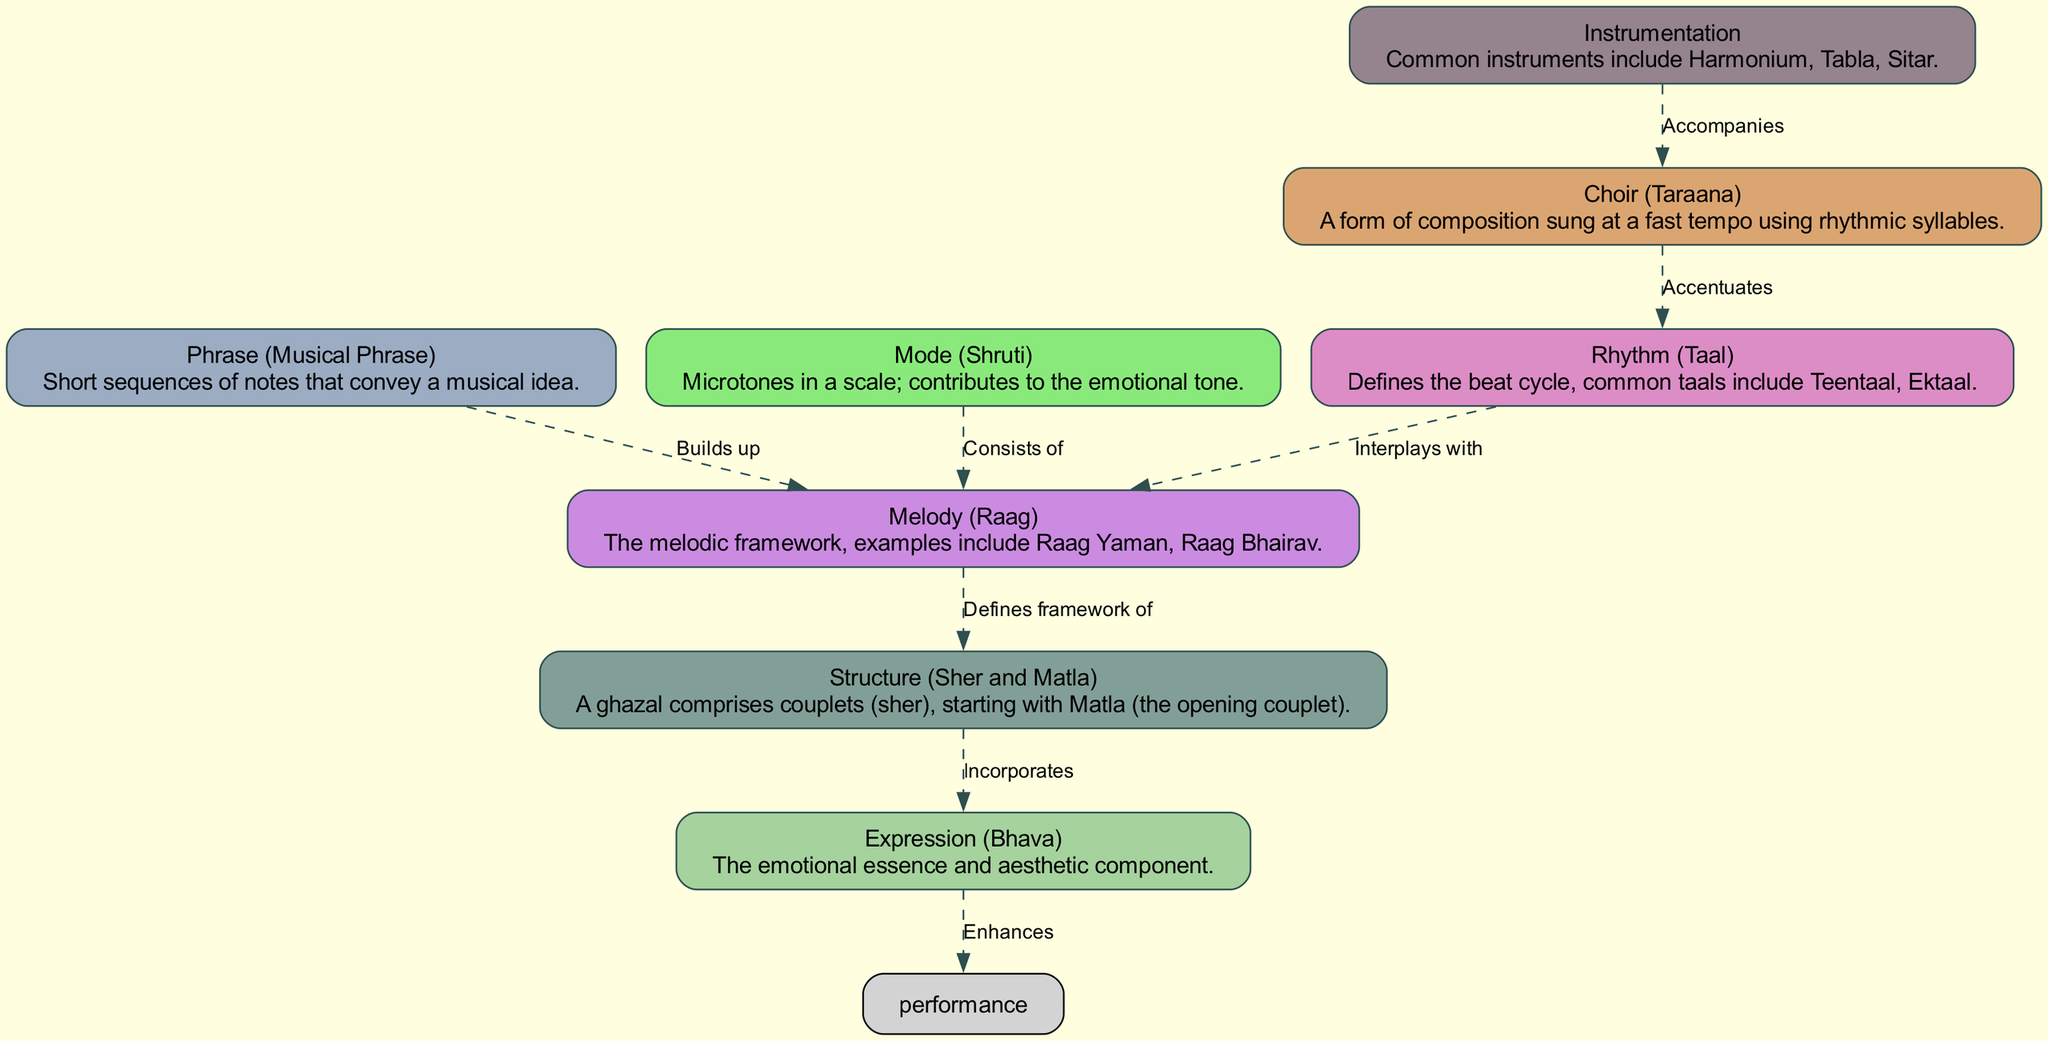What are the common taals mentioned in the diagram? The diagram describes "Rhythm (Taal)" as having common taals such as Teentaal and Ektaal. By referring to the node labeled "Rhythm (Taal)", we can directly find the answer.
Answer: Teentaal, Ektaal How many nodes are there in the diagram? The diagram has eight distinct nodes, including Rhythm (Taal), Melody (Raag), Structure (Sher and Matla), Choir (Taraana), Phrase (Musical Phrase), Mode (Shruti), Instrumentation, and Expression (Bhava). Counting these reveals that there are eight nodes in total.
Answer: 8 Which node enhances the performance according to the diagram? The diagram shows an edge from the "Expression (Bhava)" node leading to "performance" with the label "Enhances." Thus, it can be inferred that Expression (Bhava) is the node that enhances performance.
Answer: Expression (Bhava) What is the relationship between Melody (Raag) and Structure (Sher and Matla)? The diagram indicates that Melody (Raag) "Defines framework of" Structure (Sher and Matla). To answer this, we can look at the directional edge between these two nodes and the descriptive label attached to that edge.
Answer: Defines framework of Which component consists of microtones in a scale? According to the description in the node, "Mode (Shruti)" represents microtones within a scale. The information is directly referenced in the "Mode (Shruti)" definition in the diagram.
Answer: Mode (Shruti) What is the primary function of Choir (Taraana) in relation to Rhythm (Taal)? The edge labeled "Accentuates" from Choir (Taraana) to Rhythm (Taal) indicates that the Choir serves to accentuate the rhythm. Analyzing the connection and description of the edges provides this clarity.
Answer: Accentuates Which node incorporates expression into its structure? The diagram illustrates that the node "Structure (Sher and Matla)" incorporates "Expression (Bhava)." This relation is depicted through the edge pointing from Structure to Expression with the label "Incorporates."
Answer: Structure (Sher and Matla) How does Phrase (Musical Phrase) relate to Melody (Raag)? The relationship is indicated by the edge from Phrase to Melody, labeled "Builds up." This means that Musical Phrases contribute to the overall construction of the Melody, making this connection clear within the diagram.
Answer: Builds up 